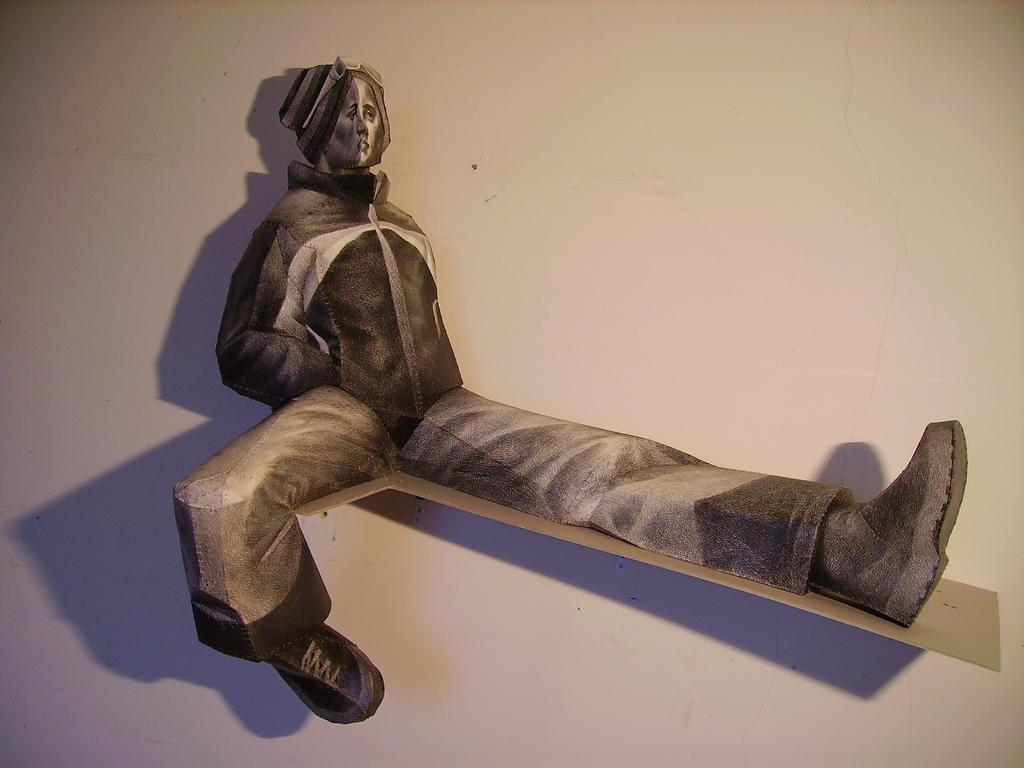What type of decorative item is in the image? The decorative item in the image is of a person. What is the decorative item placed on? The decorative item is on an object. How is the object with the decorative item attached to the wall? The object is attached to the wall. What type of honey can be seen dripping from the decorative item in the image? There is no honey present in the image; it features a decorative item of a person on an object attached to the wall. How many spiders are crawling on the decorative item in the image? There are no spiders present in the image; it features a decorative item of a person on an object attached to the wall. 